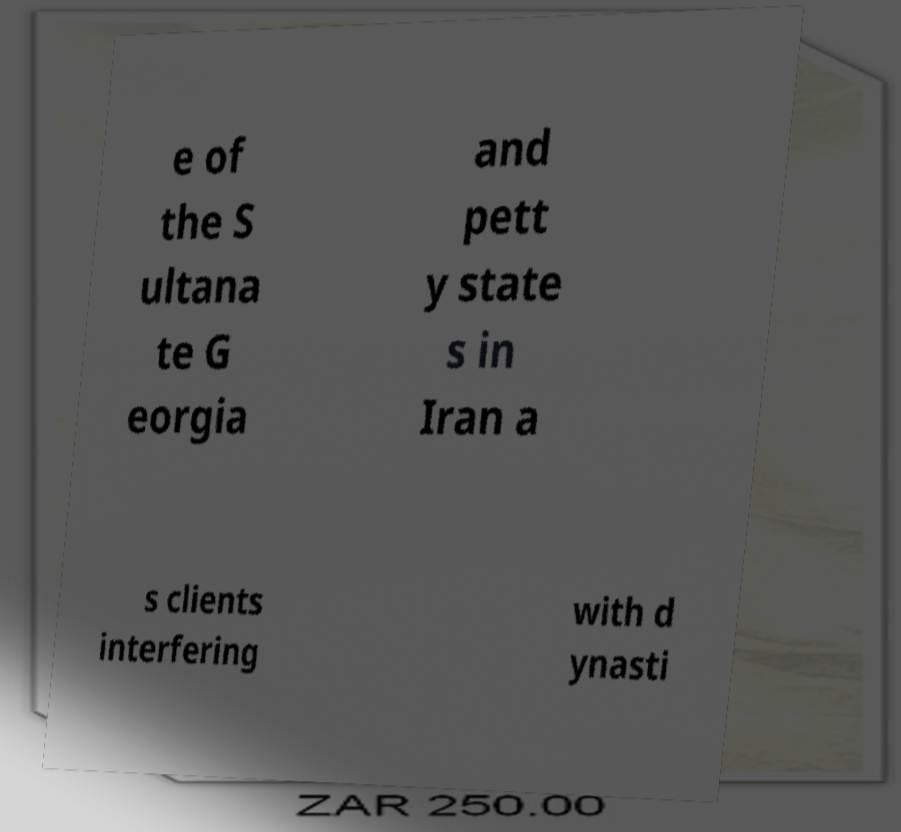Please read and relay the text visible in this image. What does it say? e of the S ultana te G eorgia and pett y state s in Iran a s clients interfering with d ynasti 